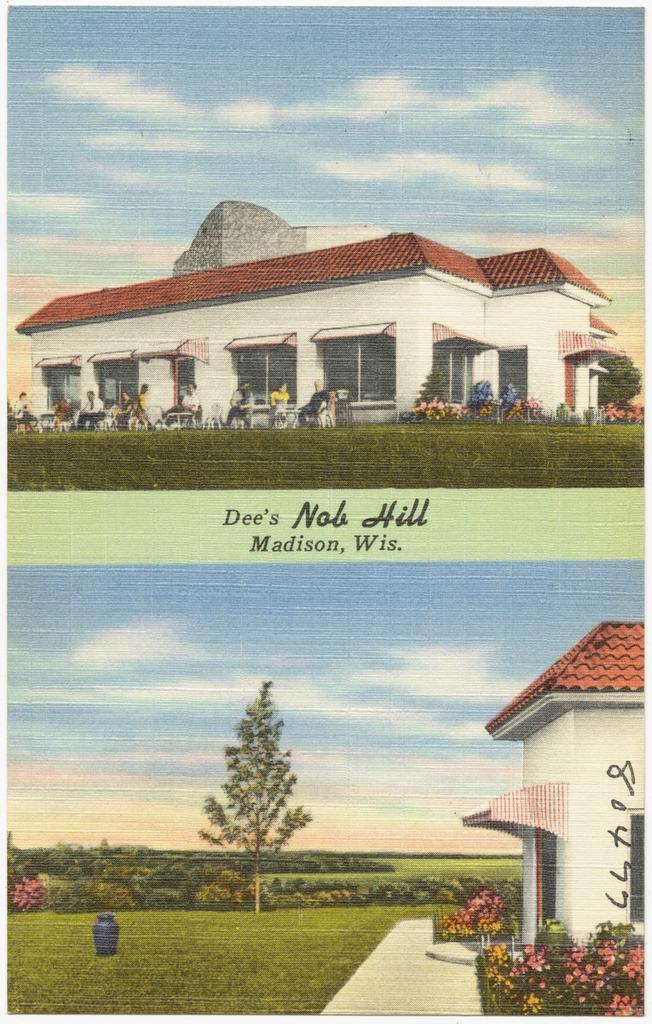Please provide a concise description of this image. In this picture I can see there is a building and there are plants, trees and there are few people sitting on the chairs and tables. There is grass on the floor and the sky is clear. 